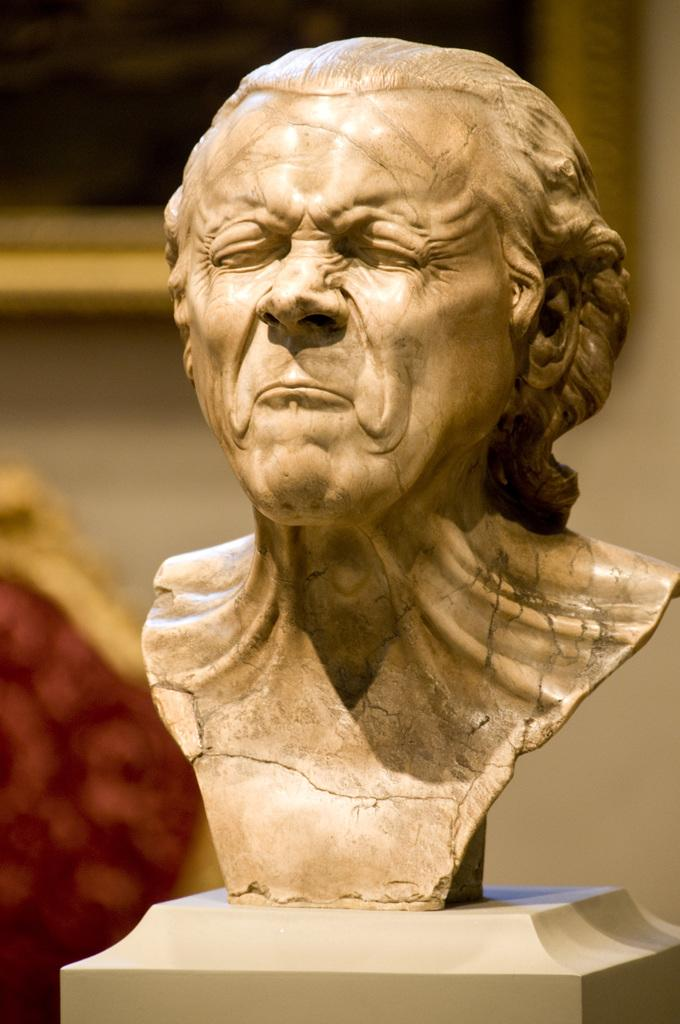What is the main subject in the center of the image? There is a sculpture in the center of the image. What can be seen in the background of the image? There is a wall and a photo frame in the background of the image. Are there any other objects visible in the background? Yes, there are other objects visible in the background of the image. How many pump trucks are visible in the image? There are no pump trucks present in the image. What type of change is being made to the sculpture in the image? There is no indication of any change being made to the sculpture in the image. 